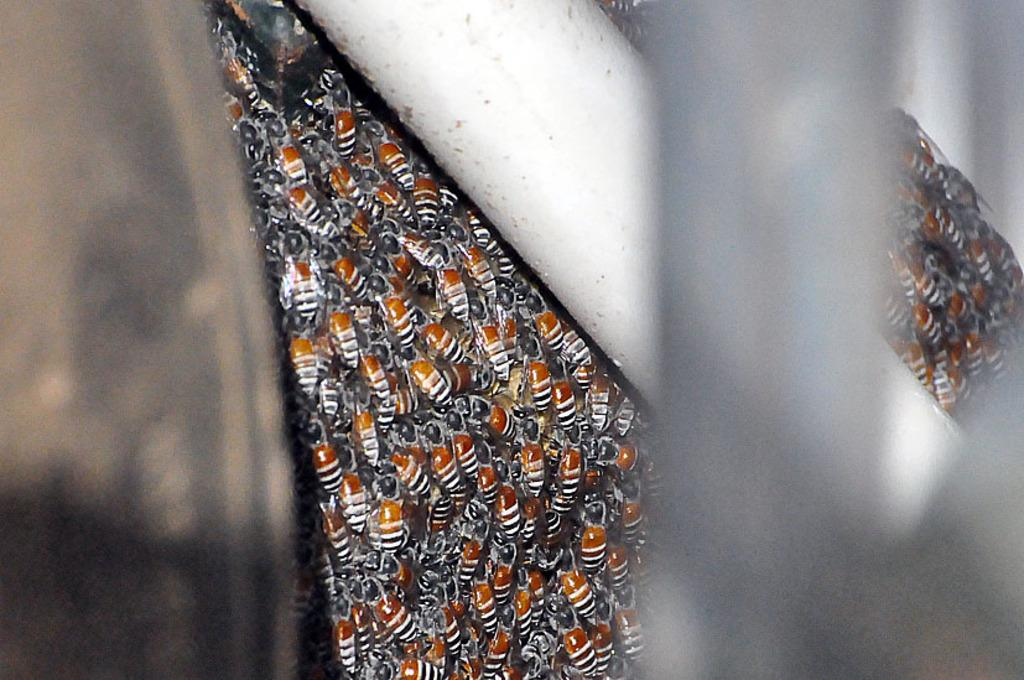What type of insects are present in the image? There are honey bees in the image. Can you describe the behavior of the honey bees in the image? The provided facts do not mention the behavior of the honey bees, so we cannot describe it. What type of food is being served in the story depicted in the image? There is no story or food present in the image; it only features honey bees. 